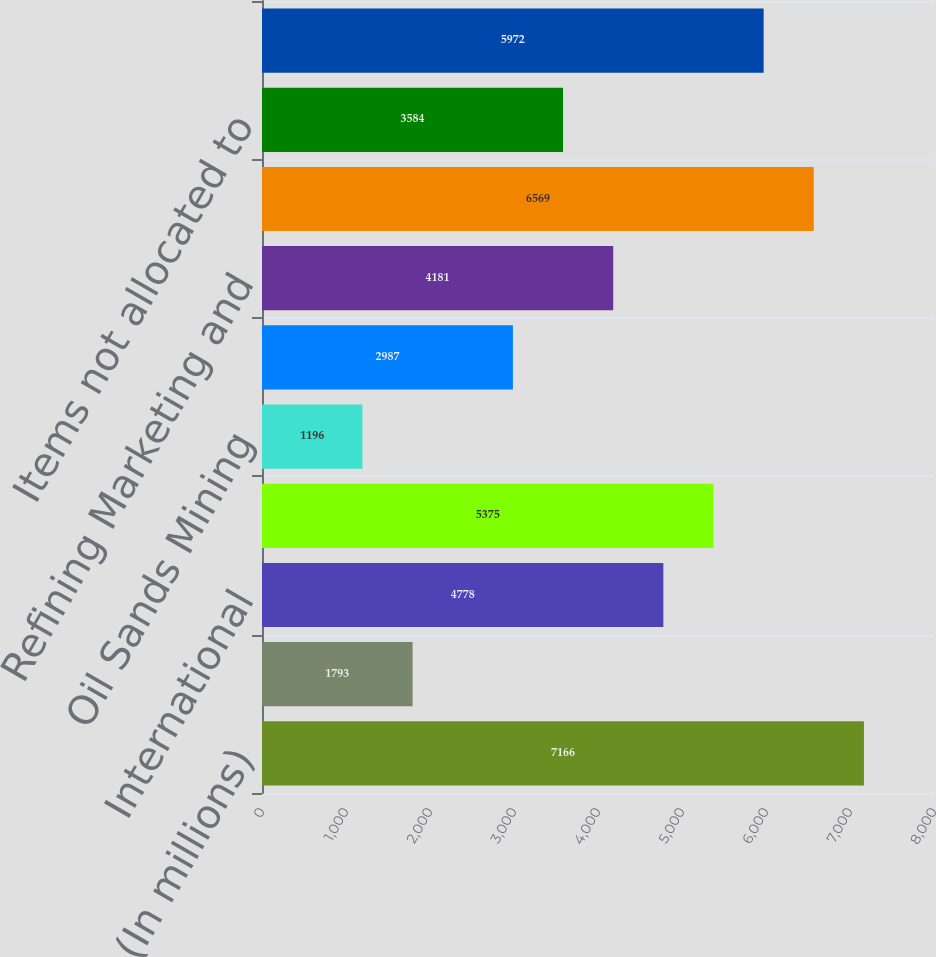Convert chart to OTSL. <chart><loc_0><loc_0><loc_500><loc_500><bar_chart><fcel>(In millions)<fcel>United States<fcel>International<fcel>E&P segment<fcel>Oil Sands Mining<fcel>Integrated Gas<fcel>Refining Marketing and<fcel>Segment income<fcel>Items not allocated to<fcel>Net income<nl><fcel>7166<fcel>1793<fcel>4778<fcel>5375<fcel>1196<fcel>2987<fcel>4181<fcel>6569<fcel>3584<fcel>5972<nl></chart> 